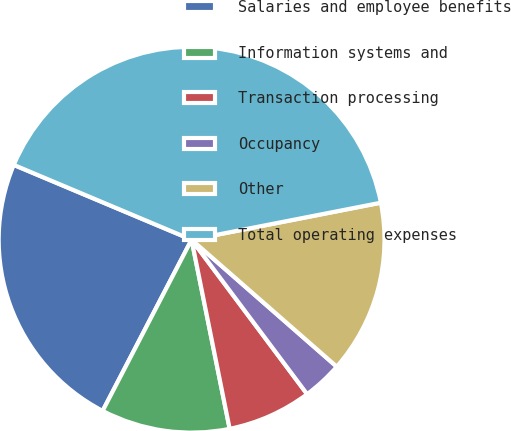Convert chart to OTSL. <chart><loc_0><loc_0><loc_500><loc_500><pie_chart><fcel>Salaries and employee benefits<fcel>Information systems and<fcel>Transaction processing<fcel>Occupancy<fcel>Other<fcel>Total operating expenses<nl><fcel>23.71%<fcel>10.79%<fcel>7.06%<fcel>3.34%<fcel>14.51%<fcel>40.59%<nl></chart> 